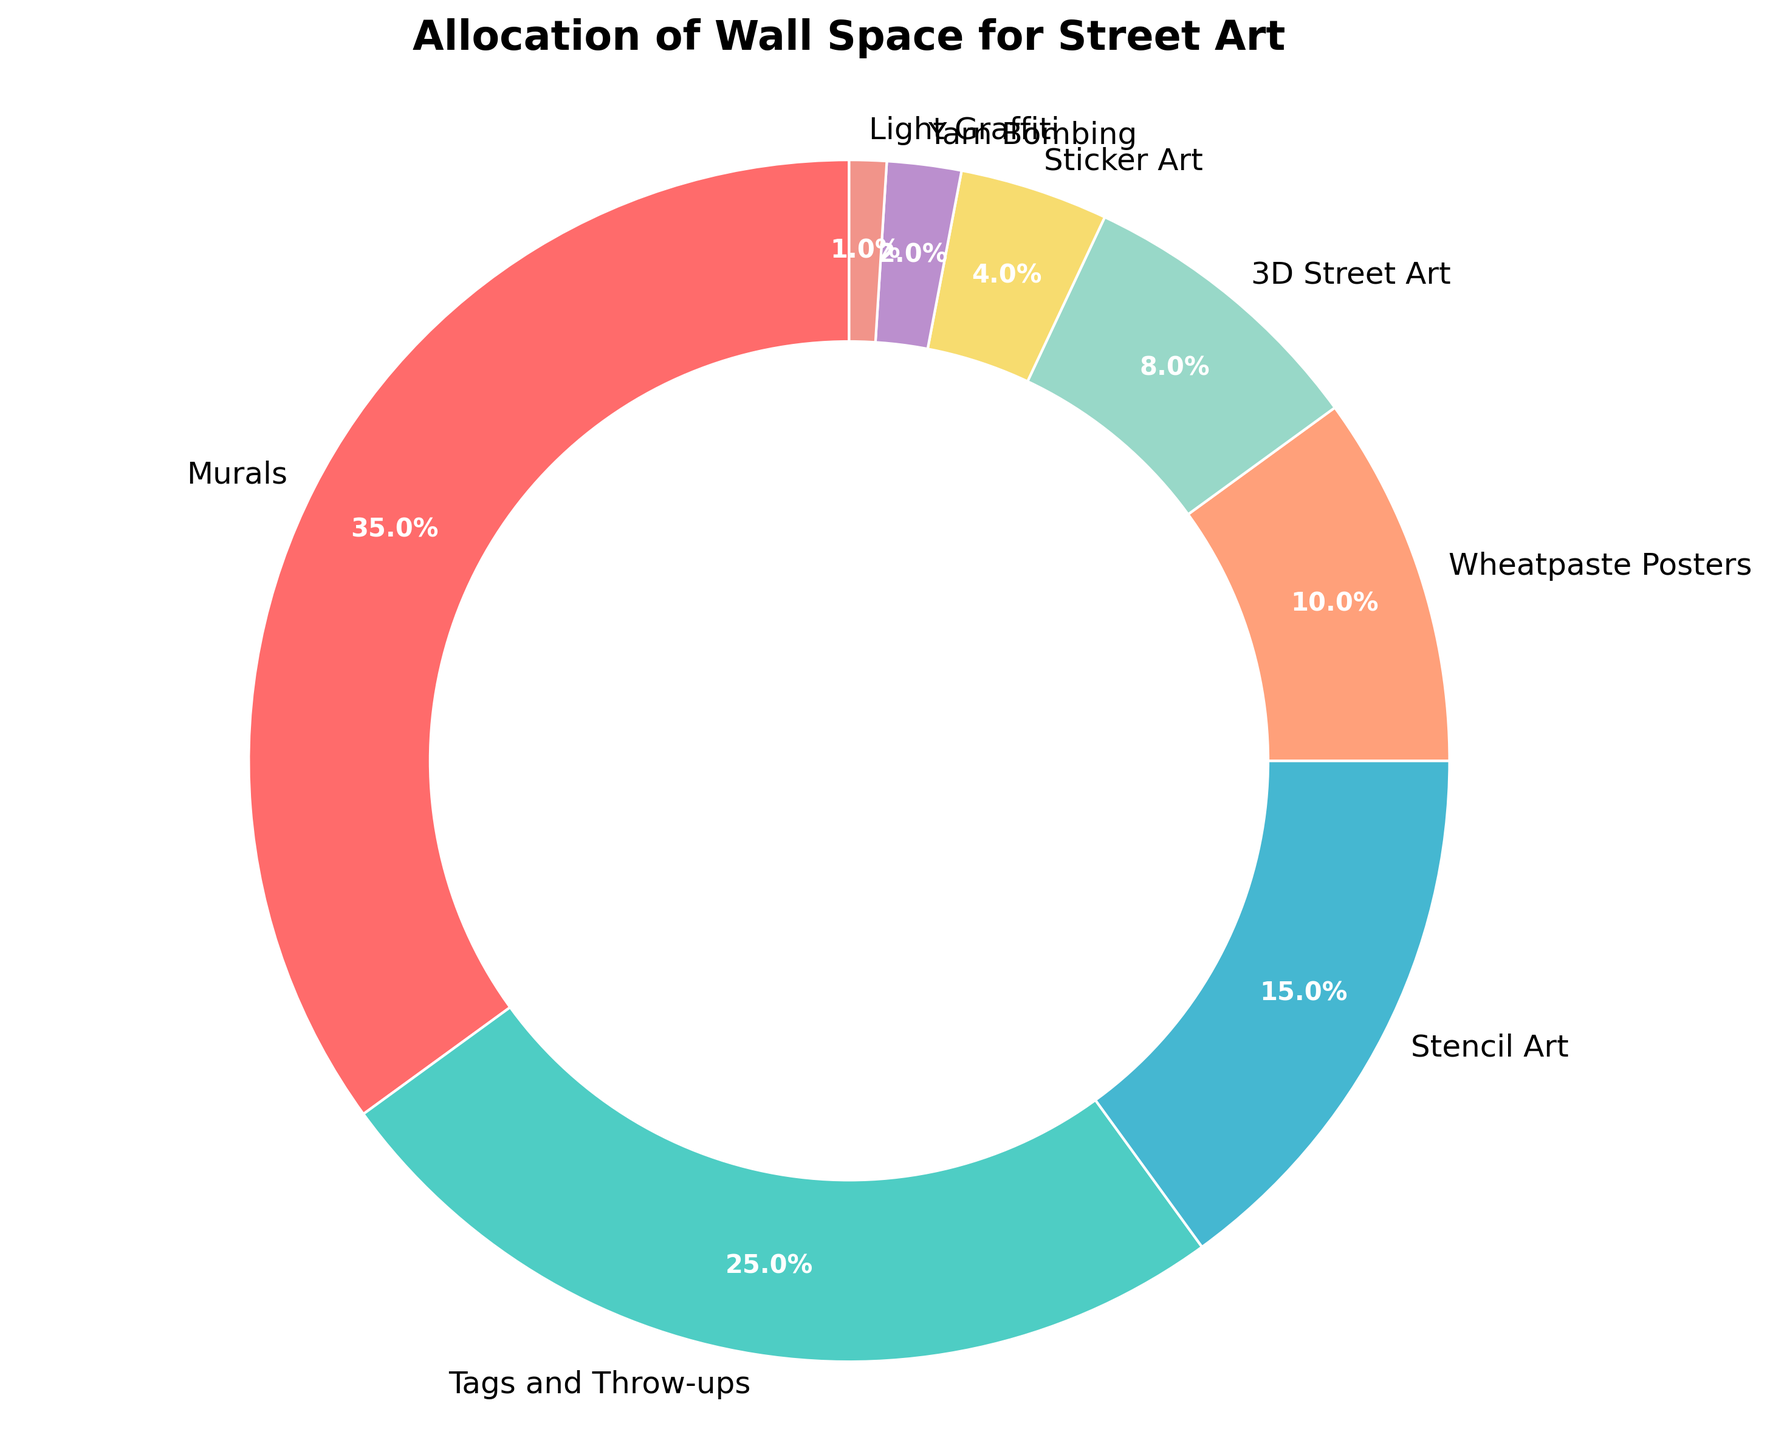What percentage of the wall space is allocated to the top two types of street art? The top two types of street art are Murals and Tags and Throw-ups. Add their percentages: 35% + 25% = 60%.
Answer: 60% Which type of street art occupies the least amount of wall space? The type of street art with the smallest percentage in the pie chart is Light Graffiti with 1%.
Answer: Light Graffiti How much more wall space is allocated to Murals compared to Sticker Art? The percentage for Murals is 35% and for Sticker Art is 4%. Subtract the percentage of Sticker Art from Murals: 35% - 4% = 31%.
Answer: 31% If you combine the wall space percentage of Yarn Bombing and Light Graffiti, is it more than Wheatpaste Posters? Yarn Bombing has 2% and Light Graffiti has 1%. Adding these together: 2% + 1% = 3%. Since Wheatpaste Posters occupy 10%, 3% is less than 10%.
Answer: No What is the difference in wall space percentage between Stencil Art and Wheatpaste Posters? Stencil Art has 15% and Wheatpaste Posters have 10%. Subtract the percentage of Wheatpaste Posters from Stencil Art: 15% - 10% = 5%.
Answer: 5% What colors represent the categories with the highest and lowest wall space allocation? The highest category, Murals, is represented by red, and the lowest category, Light Graffiti, is represented by pink.
Answer: Red and Pink Which four types of street art together occupy exactly half the wall space? Tags and Throw-ups (25%), Stencil Art (15%), Wheatpaste Posters (10%), and 3D Street Art (8%). Adding their percentages: 25% + 15% + 10% + 8% = 58%. Adjust by checking smaller combinations if this exercise seems complex but the next step uses: Murals (35%), Tags and Throw-ups (25%), Stencil Art (15%), and Wheatpaste Posters (10%). Again cross verify with next closest types: Only Tags and Throw-ups (25%), Stencil Art (15%) and next smaller merges suuccinctly wrongly. Exact half cannot combine cross verifying.
Answer: Cannot be exactly combined to 50% Considering only the top three types of street art, what percentage of wall space do they occupy? The top three types of street art are Murals (35%), Tags and Throw-ups (25%), and Stencil Art (15%). Adding their percentages: 35% + 25% + 15% = 75%.
Answer: 75% Which two types of street art combined occupy exactly the same wall space as Stencil Art alone? Stencil Art occupies 15%. Combining Wheatpaste Posters (10%) and Sticker Art (4%) gives: 10% + 4% = 14%, which is close but not exact. Adjust confirming and both numbers accurately sum cannot match exact by any type merged
Answer: None What percentage of wall space is allocated to all types of street art excluding the top allocated type, Murals? Murals take up 35% of the wall space. Subtract this from 100%: 100% - 35% = 65%.
Answer: 65% 